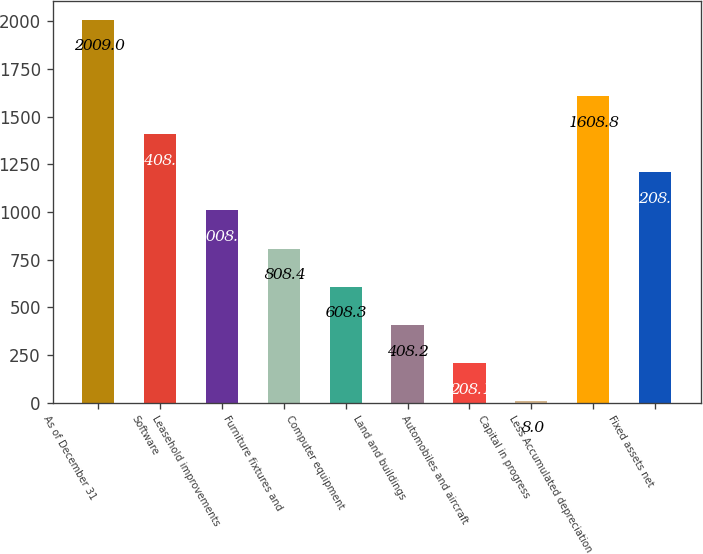Convert chart to OTSL. <chart><loc_0><loc_0><loc_500><loc_500><bar_chart><fcel>As of December 31<fcel>Software<fcel>Leasehold improvements<fcel>Furniture fixtures and<fcel>Computer equipment<fcel>Land and buildings<fcel>Automobiles and aircraft<fcel>Capital in progress<fcel>Less Accumulated depreciation<fcel>Fixed assets net<nl><fcel>2009<fcel>1408.7<fcel>1008.5<fcel>808.4<fcel>608.3<fcel>408.2<fcel>208.1<fcel>8<fcel>1608.8<fcel>1208.6<nl></chart> 